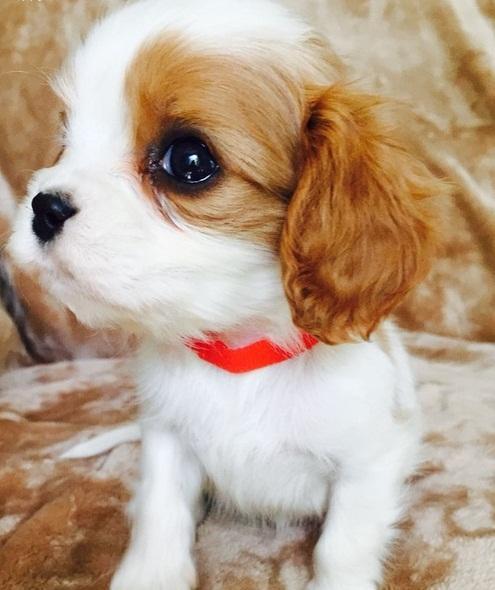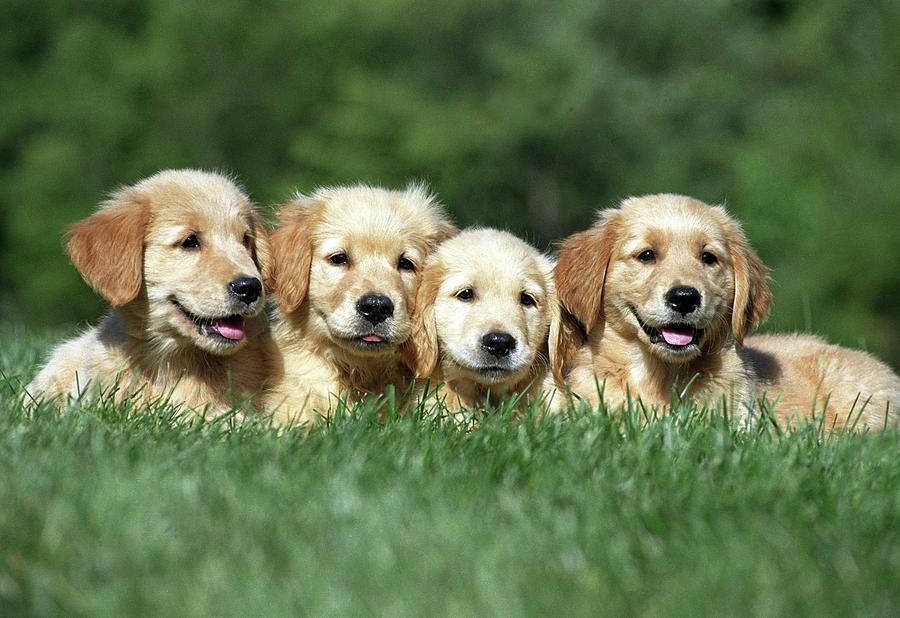The first image is the image on the left, the second image is the image on the right. For the images shown, is this caption "The right image shows a row of four young dogs." true? Answer yes or no. Yes. 